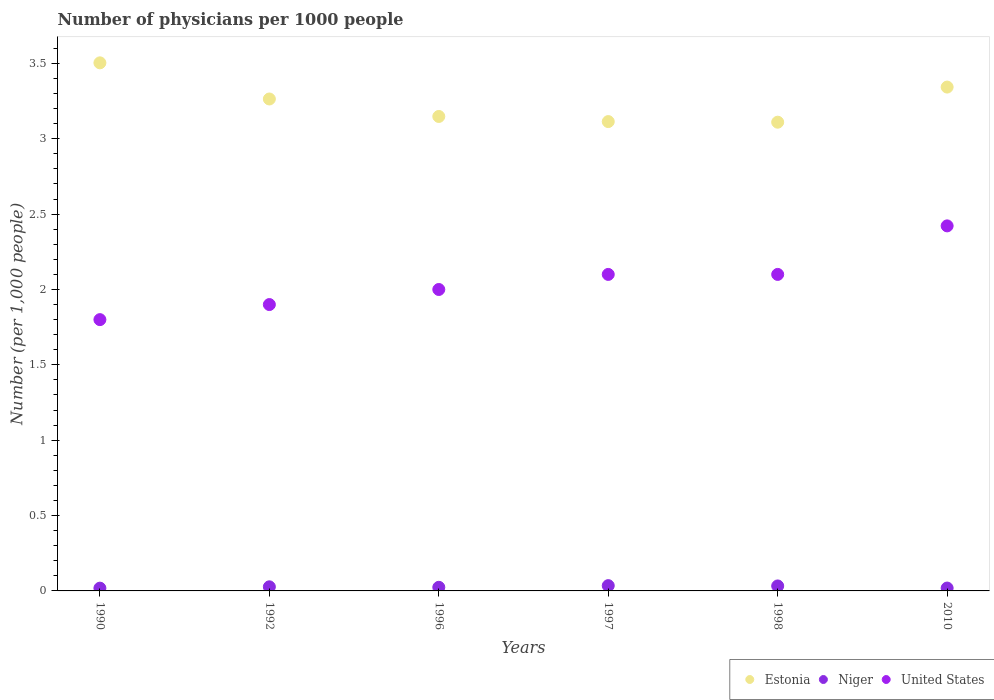What is the number of physicians in Estonia in 1998?
Offer a terse response. 3.11. Across all years, what is the maximum number of physicians in Estonia?
Your response must be concise. 3.5. Across all years, what is the minimum number of physicians in Estonia?
Give a very brief answer. 3.11. In which year was the number of physicians in Niger minimum?
Keep it short and to the point. 1990. What is the total number of physicians in United States in the graph?
Provide a short and direct response. 12.32. What is the difference between the number of physicians in Estonia in 1996 and that in 2010?
Provide a short and direct response. -0.19. What is the difference between the number of physicians in Estonia in 1992 and the number of physicians in United States in 1996?
Your response must be concise. 1.26. What is the average number of physicians in United States per year?
Provide a succinct answer. 2.05. In the year 1992, what is the difference between the number of physicians in Niger and number of physicians in United States?
Keep it short and to the point. -1.87. In how many years, is the number of physicians in Estonia greater than 1.5?
Your answer should be very brief. 6. What is the ratio of the number of physicians in Estonia in 1992 to that in 1997?
Your answer should be very brief. 1.05. Is the number of physicians in United States in 1996 less than that in 1998?
Your answer should be compact. Yes. What is the difference between the highest and the second highest number of physicians in Estonia?
Your answer should be compact. 0.16. What is the difference between the highest and the lowest number of physicians in United States?
Offer a terse response. 0.62. Is the sum of the number of physicians in Estonia in 1992 and 1996 greater than the maximum number of physicians in Niger across all years?
Keep it short and to the point. Yes. Is it the case that in every year, the sum of the number of physicians in Estonia and number of physicians in Niger  is greater than the number of physicians in United States?
Offer a terse response. Yes. Is the number of physicians in Niger strictly less than the number of physicians in Estonia over the years?
Offer a very short reply. Yes. How many dotlines are there?
Offer a very short reply. 3. Does the graph contain grids?
Make the answer very short. No. How are the legend labels stacked?
Give a very brief answer. Horizontal. What is the title of the graph?
Offer a very short reply. Number of physicians per 1000 people. What is the label or title of the X-axis?
Ensure brevity in your answer.  Years. What is the label or title of the Y-axis?
Your answer should be compact. Number (per 1,0 people). What is the Number (per 1,000 people) of Estonia in 1990?
Give a very brief answer. 3.5. What is the Number (per 1,000 people) in Niger in 1990?
Your answer should be very brief. 0.02. What is the Number (per 1,000 people) of Estonia in 1992?
Provide a succinct answer. 3.26. What is the Number (per 1,000 people) in Niger in 1992?
Offer a very short reply. 0.03. What is the Number (per 1,000 people) of Estonia in 1996?
Keep it short and to the point. 3.15. What is the Number (per 1,000 people) of Niger in 1996?
Your response must be concise. 0.02. What is the Number (per 1,000 people) in Estonia in 1997?
Your response must be concise. 3.11. What is the Number (per 1,000 people) of Niger in 1997?
Your answer should be compact. 0.04. What is the Number (per 1,000 people) of Estonia in 1998?
Your answer should be compact. 3.11. What is the Number (per 1,000 people) in Niger in 1998?
Your response must be concise. 0.03. What is the Number (per 1,000 people) in United States in 1998?
Make the answer very short. 2.1. What is the Number (per 1,000 people) of Estonia in 2010?
Offer a very short reply. 3.34. What is the Number (per 1,000 people) in Niger in 2010?
Your response must be concise. 0.02. What is the Number (per 1,000 people) in United States in 2010?
Keep it short and to the point. 2.42. Across all years, what is the maximum Number (per 1,000 people) of Estonia?
Make the answer very short. 3.5. Across all years, what is the maximum Number (per 1,000 people) of Niger?
Ensure brevity in your answer.  0.04. Across all years, what is the maximum Number (per 1,000 people) of United States?
Offer a terse response. 2.42. Across all years, what is the minimum Number (per 1,000 people) in Estonia?
Ensure brevity in your answer.  3.11. Across all years, what is the minimum Number (per 1,000 people) of Niger?
Make the answer very short. 0.02. What is the total Number (per 1,000 people) in Estonia in the graph?
Ensure brevity in your answer.  19.48. What is the total Number (per 1,000 people) in Niger in the graph?
Your response must be concise. 0.16. What is the total Number (per 1,000 people) of United States in the graph?
Keep it short and to the point. 12.32. What is the difference between the Number (per 1,000 people) in Estonia in 1990 and that in 1992?
Offer a terse response. 0.24. What is the difference between the Number (per 1,000 people) in Niger in 1990 and that in 1992?
Your response must be concise. -0.01. What is the difference between the Number (per 1,000 people) in United States in 1990 and that in 1992?
Your answer should be compact. -0.1. What is the difference between the Number (per 1,000 people) of Estonia in 1990 and that in 1996?
Provide a succinct answer. 0.36. What is the difference between the Number (per 1,000 people) in Niger in 1990 and that in 1996?
Your response must be concise. -0.01. What is the difference between the Number (per 1,000 people) in United States in 1990 and that in 1996?
Your response must be concise. -0.2. What is the difference between the Number (per 1,000 people) of Estonia in 1990 and that in 1997?
Your answer should be very brief. 0.39. What is the difference between the Number (per 1,000 people) of Niger in 1990 and that in 1997?
Provide a short and direct response. -0.02. What is the difference between the Number (per 1,000 people) of United States in 1990 and that in 1997?
Give a very brief answer. -0.3. What is the difference between the Number (per 1,000 people) of Estonia in 1990 and that in 1998?
Your response must be concise. 0.39. What is the difference between the Number (per 1,000 people) of Niger in 1990 and that in 1998?
Offer a very short reply. -0.01. What is the difference between the Number (per 1,000 people) of United States in 1990 and that in 1998?
Provide a short and direct response. -0.3. What is the difference between the Number (per 1,000 people) in Estonia in 1990 and that in 2010?
Offer a terse response. 0.16. What is the difference between the Number (per 1,000 people) of Niger in 1990 and that in 2010?
Make the answer very short. -0. What is the difference between the Number (per 1,000 people) in United States in 1990 and that in 2010?
Provide a short and direct response. -0.62. What is the difference between the Number (per 1,000 people) in Estonia in 1992 and that in 1996?
Provide a short and direct response. 0.12. What is the difference between the Number (per 1,000 people) in Niger in 1992 and that in 1996?
Offer a very short reply. 0. What is the difference between the Number (per 1,000 people) in Niger in 1992 and that in 1997?
Your answer should be very brief. -0.01. What is the difference between the Number (per 1,000 people) in Estonia in 1992 and that in 1998?
Your answer should be compact. 0.15. What is the difference between the Number (per 1,000 people) of Niger in 1992 and that in 1998?
Give a very brief answer. -0.01. What is the difference between the Number (per 1,000 people) in Estonia in 1992 and that in 2010?
Make the answer very short. -0.08. What is the difference between the Number (per 1,000 people) of Niger in 1992 and that in 2010?
Provide a short and direct response. 0.01. What is the difference between the Number (per 1,000 people) of United States in 1992 and that in 2010?
Provide a short and direct response. -0.52. What is the difference between the Number (per 1,000 people) of Estonia in 1996 and that in 1997?
Offer a terse response. 0.03. What is the difference between the Number (per 1,000 people) of Niger in 1996 and that in 1997?
Provide a short and direct response. -0.01. What is the difference between the Number (per 1,000 people) of Estonia in 1996 and that in 1998?
Your answer should be compact. 0.04. What is the difference between the Number (per 1,000 people) in Niger in 1996 and that in 1998?
Provide a short and direct response. -0.01. What is the difference between the Number (per 1,000 people) of United States in 1996 and that in 1998?
Your answer should be compact. -0.1. What is the difference between the Number (per 1,000 people) in Estonia in 1996 and that in 2010?
Offer a terse response. -0.2. What is the difference between the Number (per 1,000 people) of Niger in 1996 and that in 2010?
Provide a succinct answer. 0.01. What is the difference between the Number (per 1,000 people) in United States in 1996 and that in 2010?
Your answer should be compact. -0.42. What is the difference between the Number (per 1,000 people) of Estonia in 1997 and that in 1998?
Make the answer very short. 0. What is the difference between the Number (per 1,000 people) of Niger in 1997 and that in 1998?
Offer a terse response. 0. What is the difference between the Number (per 1,000 people) of United States in 1997 and that in 1998?
Offer a terse response. 0. What is the difference between the Number (per 1,000 people) of Estonia in 1997 and that in 2010?
Your response must be concise. -0.23. What is the difference between the Number (per 1,000 people) of Niger in 1997 and that in 2010?
Provide a short and direct response. 0.02. What is the difference between the Number (per 1,000 people) in United States in 1997 and that in 2010?
Your response must be concise. -0.32. What is the difference between the Number (per 1,000 people) of Estonia in 1998 and that in 2010?
Make the answer very short. -0.23. What is the difference between the Number (per 1,000 people) in Niger in 1998 and that in 2010?
Offer a terse response. 0.01. What is the difference between the Number (per 1,000 people) of United States in 1998 and that in 2010?
Ensure brevity in your answer.  -0.32. What is the difference between the Number (per 1,000 people) in Estonia in 1990 and the Number (per 1,000 people) in Niger in 1992?
Your answer should be very brief. 3.48. What is the difference between the Number (per 1,000 people) of Estonia in 1990 and the Number (per 1,000 people) of United States in 1992?
Provide a succinct answer. 1.6. What is the difference between the Number (per 1,000 people) in Niger in 1990 and the Number (per 1,000 people) in United States in 1992?
Your answer should be very brief. -1.88. What is the difference between the Number (per 1,000 people) of Estonia in 1990 and the Number (per 1,000 people) of Niger in 1996?
Provide a succinct answer. 3.48. What is the difference between the Number (per 1,000 people) of Estonia in 1990 and the Number (per 1,000 people) of United States in 1996?
Keep it short and to the point. 1.5. What is the difference between the Number (per 1,000 people) of Niger in 1990 and the Number (per 1,000 people) of United States in 1996?
Ensure brevity in your answer.  -1.98. What is the difference between the Number (per 1,000 people) of Estonia in 1990 and the Number (per 1,000 people) of Niger in 1997?
Offer a terse response. 3.47. What is the difference between the Number (per 1,000 people) of Estonia in 1990 and the Number (per 1,000 people) of United States in 1997?
Offer a very short reply. 1.4. What is the difference between the Number (per 1,000 people) of Niger in 1990 and the Number (per 1,000 people) of United States in 1997?
Your response must be concise. -2.08. What is the difference between the Number (per 1,000 people) of Estonia in 1990 and the Number (per 1,000 people) of Niger in 1998?
Provide a short and direct response. 3.47. What is the difference between the Number (per 1,000 people) of Estonia in 1990 and the Number (per 1,000 people) of United States in 1998?
Provide a short and direct response. 1.4. What is the difference between the Number (per 1,000 people) in Niger in 1990 and the Number (per 1,000 people) in United States in 1998?
Provide a short and direct response. -2.08. What is the difference between the Number (per 1,000 people) of Estonia in 1990 and the Number (per 1,000 people) of Niger in 2010?
Offer a terse response. 3.48. What is the difference between the Number (per 1,000 people) of Estonia in 1990 and the Number (per 1,000 people) of United States in 2010?
Provide a succinct answer. 1.08. What is the difference between the Number (per 1,000 people) in Niger in 1990 and the Number (per 1,000 people) in United States in 2010?
Make the answer very short. -2.4. What is the difference between the Number (per 1,000 people) in Estonia in 1992 and the Number (per 1,000 people) in Niger in 1996?
Your answer should be compact. 3.24. What is the difference between the Number (per 1,000 people) in Estonia in 1992 and the Number (per 1,000 people) in United States in 1996?
Keep it short and to the point. 1.26. What is the difference between the Number (per 1,000 people) of Niger in 1992 and the Number (per 1,000 people) of United States in 1996?
Provide a short and direct response. -1.97. What is the difference between the Number (per 1,000 people) in Estonia in 1992 and the Number (per 1,000 people) in Niger in 1997?
Provide a succinct answer. 3.23. What is the difference between the Number (per 1,000 people) in Estonia in 1992 and the Number (per 1,000 people) in United States in 1997?
Make the answer very short. 1.16. What is the difference between the Number (per 1,000 people) in Niger in 1992 and the Number (per 1,000 people) in United States in 1997?
Your response must be concise. -2.07. What is the difference between the Number (per 1,000 people) in Estonia in 1992 and the Number (per 1,000 people) in Niger in 1998?
Your answer should be compact. 3.23. What is the difference between the Number (per 1,000 people) in Estonia in 1992 and the Number (per 1,000 people) in United States in 1998?
Make the answer very short. 1.16. What is the difference between the Number (per 1,000 people) in Niger in 1992 and the Number (per 1,000 people) in United States in 1998?
Provide a succinct answer. -2.07. What is the difference between the Number (per 1,000 people) of Estonia in 1992 and the Number (per 1,000 people) of Niger in 2010?
Make the answer very short. 3.25. What is the difference between the Number (per 1,000 people) of Estonia in 1992 and the Number (per 1,000 people) of United States in 2010?
Keep it short and to the point. 0.84. What is the difference between the Number (per 1,000 people) of Niger in 1992 and the Number (per 1,000 people) of United States in 2010?
Offer a terse response. -2.39. What is the difference between the Number (per 1,000 people) in Estonia in 1996 and the Number (per 1,000 people) in Niger in 1997?
Ensure brevity in your answer.  3.11. What is the difference between the Number (per 1,000 people) of Estonia in 1996 and the Number (per 1,000 people) of United States in 1997?
Your response must be concise. 1.05. What is the difference between the Number (per 1,000 people) in Niger in 1996 and the Number (per 1,000 people) in United States in 1997?
Make the answer very short. -2.08. What is the difference between the Number (per 1,000 people) of Estonia in 1996 and the Number (per 1,000 people) of Niger in 1998?
Keep it short and to the point. 3.12. What is the difference between the Number (per 1,000 people) of Estonia in 1996 and the Number (per 1,000 people) of United States in 1998?
Keep it short and to the point. 1.05. What is the difference between the Number (per 1,000 people) in Niger in 1996 and the Number (per 1,000 people) in United States in 1998?
Ensure brevity in your answer.  -2.08. What is the difference between the Number (per 1,000 people) of Estonia in 1996 and the Number (per 1,000 people) of Niger in 2010?
Your response must be concise. 3.13. What is the difference between the Number (per 1,000 people) of Estonia in 1996 and the Number (per 1,000 people) of United States in 2010?
Your answer should be very brief. 0.73. What is the difference between the Number (per 1,000 people) in Niger in 1996 and the Number (per 1,000 people) in United States in 2010?
Your answer should be compact. -2.4. What is the difference between the Number (per 1,000 people) of Estonia in 1997 and the Number (per 1,000 people) of Niger in 1998?
Your response must be concise. 3.08. What is the difference between the Number (per 1,000 people) in Estonia in 1997 and the Number (per 1,000 people) in United States in 1998?
Provide a succinct answer. 1.01. What is the difference between the Number (per 1,000 people) in Niger in 1997 and the Number (per 1,000 people) in United States in 1998?
Keep it short and to the point. -2.06. What is the difference between the Number (per 1,000 people) of Estonia in 1997 and the Number (per 1,000 people) of Niger in 2010?
Provide a short and direct response. 3.1. What is the difference between the Number (per 1,000 people) in Estonia in 1997 and the Number (per 1,000 people) in United States in 2010?
Your answer should be very brief. 0.69. What is the difference between the Number (per 1,000 people) in Niger in 1997 and the Number (per 1,000 people) in United States in 2010?
Your answer should be very brief. -2.39. What is the difference between the Number (per 1,000 people) in Estonia in 1998 and the Number (per 1,000 people) in Niger in 2010?
Ensure brevity in your answer.  3.09. What is the difference between the Number (per 1,000 people) in Estonia in 1998 and the Number (per 1,000 people) in United States in 2010?
Make the answer very short. 0.69. What is the difference between the Number (per 1,000 people) of Niger in 1998 and the Number (per 1,000 people) of United States in 2010?
Make the answer very short. -2.39. What is the average Number (per 1,000 people) in Estonia per year?
Give a very brief answer. 3.25. What is the average Number (per 1,000 people) of Niger per year?
Your answer should be compact. 0.03. What is the average Number (per 1,000 people) in United States per year?
Ensure brevity in your answer.  2.05. In the year 1990, what is the difference between the Number (per 1,000 people) in Estonia and Number (per 1,000 people) in Niger?
Provide a short and direct response. 3.49. In the year 1990, what is the difference between the Number (per 1,000 people) in Estonia and Number (per 1,000 people) in United States?
Make the answer very short. 1.7. In the year 1990, what is the difference between the Number (per 1,000 people) of Niger and Number (per 1,000 people) of United States?
Your answer should be very brief. -1.78. In the year 1992, what is the difference between the Number (per 1,000 people) in Estonia and Number (per 1,000 people) in Niger?
Your answer should be compact. 3.24. In the year 1992, what is the difference between the Number (per 1,000 people) in Estonia and Number (per 1,000 people) in United States?
Make the answer very short. 1.36. In the year 1992, what is the difference between the Number (per 1,000 people) of Niger and Number (per 1,000 people) of United States?
Provide a short and direct response. -1.87. In the year 1996, what is the difference between the Number (per 1,000 people) of Estonia and Number (per 1,000 people) of Niger?
Keep it short and to the point. 3.12. In the year 1996, what is the difference between the Number (per 1,000 people) of Estonia and Number (per 1,000 people) of United States?
Give a very brief answer. 1.15. In the year 1996, what is the difference between the Number (per 1,000 people) in Niger and Number (per 1,000 people) in United States?
Ensure brevity in your answer.  -1.98. In the year 1997, what is the difference between the Number (per 1,000 people) in Estonia and Number (per 1,000 people) in Niger?
Ensure brevity in your answer.  3.08. In the year 1997, what is the difference between the Number (per 1,000 people) of Estonia and Number (per 1,000 people) of United States?
Offer a very short reply. 1.01. In the year 1997, what is the difference between the Number (per 1,000 people) in Niger and Number (per 1,000 people) in United States?
Your answer should be compact. -2.06. In the year 1998, what is the difference between the Number (per 1,000 people) in Estonia and Number (per 1,000 people) in Niger?
Your answer should be compact. 3.08. In the year 1998, what is the difference between the Number (per 1,000 people) of Estonia and Number (per 1,000 people) of United States?
Offer a very short reply. 1.01. In the year 1998, what is the difference between the Number (per 1,000 people) in Niger and Number (per 1,000 people) in United States?
Provide a short and direct response. -2.07. In the year 2010, what is the difference between the Number (per 1,000 people) of Estonia and Number (per 1,000 people) of Niger?
Provide a succinct answer. 3.32. In the year 2010, what is the difference between the Number (per 1,000 people) of Estonia and Number (per 1,000 people) of United States?
Your response must be concise. 0.92. In the year 2010, what is the difference between the Number (per 1,000 people) in Niger and Number (per 1,000 people) in United States?
Your answer should be very brief. -2.4. What is the ratio of the Number (per 1,000 people) of Estonia in 1990 to that in 1992?
Make the answer very short. 1.07. What is the ratio of the Number (per 1,000 people) of Niger in 1990 to that in 1992?
Your answer should be very brief. 0.68. What is the ratio of the Number (per 1,000 people) of Estonia in 1990 to that in 1996?
Provide a succinct answer. 1.11. What is the ratio of the Number (per 1,000 people) in Niger in 1990 to that in 1996?
Your answer should be compact. 0.77. What is the ratio of the Number (per 1,000 people) in United States in 1990 to that in 1996?
Keep it short and to the point. 0.9. What is the ratio of the Number (per 1,000 people) in Estonia in 1990 to that in 1997?
Provide a short and direct response. 1.13. What is the ratio of the Number (per 1,000 people) of Niger in 1990 to that in 1997?
Give a very brief answer. 0.53. What is the ratio of the Number (per 1,000 people) of Estonia in 1990 to that in 1998?
Make the answer very short. 1.13. What is the ratio of the Number (per 1,000 people) of Niger in 1990 to that in 1998?
Ensure brevity in your answer.  0.56. What is the ratio of the Number (per 1,000 people) of Estonia in 1990 to that in 2010?
Provide a short and direct response. 1.05. What is the ratio of the Number (per 1,000 people) in Niger in 1990 to that in 2010?
Your answer should be compact. 0.97. What is the ratio of the Number (per 1,000 people) in United States in 1990 to that in 2010?
Ensure brevity in your answer.  0.74. What is the ratio of the Number (per 1,000 people) of Estonia in 1992 to that in 1996?
Offer a very short reply. 1.04. What is the ratio of the Number (per 1,000 people) of Niger in 1992 to that in 1996?
Offer a very short reply. 1.13. What is the ratio of the Number (per 1,000 people) of United States in 1992 to that in 1996?
Give a very brief answer. 0.95. What is the ratio of the Number (per 1,000 people) in Estonia in 1992 to that in 1997?
Offer a terse response. 1.05. What is the ratio of the Number (per 1,000 people) in Niger in 1992 to that in 1997?
Make the answer very short. 0.78. What is the ratio of the Number (per 1,000 people) of United States in 1992 to that in 1997?
Provide a succinct answer. 0.9. What is the ratio of the Number (per 1,000 people) in Estonia in 1992 to that in 1998?
Provide a short and direct response. 1.05. What is the ratio of the Number (per 1,000 people) in Niger in 1992 to that in 1998?
Your answer should be very brief. 0.82. What is the ratio of the Number (per 1,000 people) in United States in 1992 to that in 1998?
Offer a very short reply. 0.9. What is the ratio of the Number (per 1,000 people) of Estonia in 1992 to that in 2010?
Provide a short and direct response. 0.98. What is the ratio of the Number (per 1,000 people) in Niger in 1992 to that in 2010?
Provide a short and direct response. 1.43. What is the ratio of the Number (per 1,000 people) in United States in 1992 to that in 2010?
Your answer should be very brief. 0.78. What is the ratio of the Number (per 1,000 people) in Estonia in 1996 to that in 1997?
Ensure brevity in your answer.  1.01. What is the ratio of the Number (per 1,000 people) in Niger in 1996 to that in 1997?
Give a very brief answer. 0.69. What is the ratio of the Number (per 1,000 people) in United States in 1996 to that in 1997?
Provide a short and direct response. 0.95. What is the ratio of the Number (per 1,000 people) in Estonia in 1996 to that in 1998?
Give a very brief answer. 1.01. What is the ratio of the Number (per 1,000 people) in Niger in 1996 to that in 1998?
Give a very brief answer. 0.73. What is the ratio of the Number (per 1,000 people) of United States in 1996 to that in 1998?
Your answer should be compact. 0.95. What is the ratio of the Number (per 1,000 people) in Estonia in 1996 to that in 2010?
Provide a short and direct response. 0.94. What is the ratio of the Number (per 1,000 people) of Niger in 1996 to that in 2010?
Keep it short and to the point. 1.26. What is the ratio of the Number (per 1,000 people) in United States in 1996 to that in 2010?
Make the answer very short. 0.83. What is the ratio of the Number (per 1,000 people) in Estonia in 1997 to that in 1998?
Offer a terse response. 1. What is the ratio of the Number (per 1,000 people) in Niger in 1997 to that in 1998?
Ensure brevity in your answer.  1.06. What is the ratio of the Number (per 1,000 people) in United States in 1997 to that in 1998?
Give a very brief answer. 1. What is the ratio of the Number (per 1,000 people) of Estonia in 1997 to that in 2010?
Ensure brevity in your answer.  0.93. What is the ratio of the Number (per 1,000 people) in Niger in 1997 to that in 2010?
Keep it short and to the point. 1.84. What is the ratio of the Number (per 1,000 people) in United States in 1997 to that in 2010?
Keep it short and to the point. 0.87. What is the ratio of the Number (per 1,000 people) of Estonia in 1998 to that in 2010?
Offer a very short reply. 0.93. What is the ratio of the Number (per 1,000 people) in Niger in 1998 to that in 2010?
Make the answer very short. 1.74. What is the ratio of the Number (per 1,000 people) in United States in 1998 to that in 2010?
Provide a succinct answer. 0.87. What is the difference between the highest and the second highest Number (per 1,000 people) of Estonia?
Ensure brevity in your answer.  0.16. What is the difference between the highest and the second highest Number (per 1,000 people) in Niger?
Offer a terse response. 0. What is the difference between the highest and the second highest Number (per 1,000 people) in United States?
Your response must be concise. 0.32. What is the difference between the highest and the lowest Number (per 1,000 people) of Estonia?
Your answer should be very brief. 0.39. What is the difference between the highest and the lowest Number (per 1,000 people) of Niger?
Offer a terse response. 0.02. What is the difference between the highest and the lowest Number (per 1,000 people) of United States?
Keep it short and to the point. 0.62. 